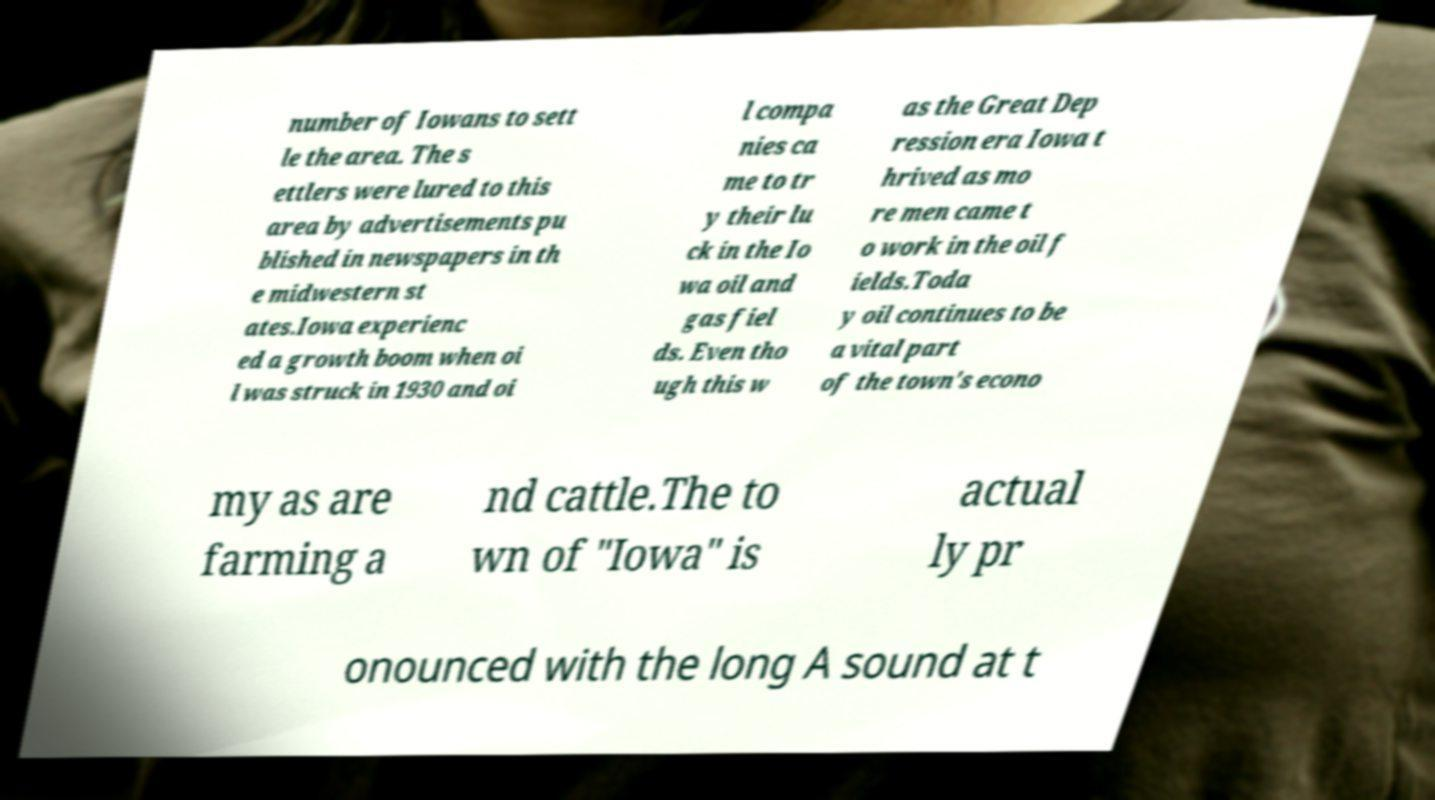What messages or text are displayed in this image? I need them in a readable, typed format. number of Iowans to sett le the area. The s ettlers were lured to this area by advertisements pu blished in newspapers in th e midwestern st ates.Iowa experienc ed a growth boom when oi l was struck in 1930 and oi l compa nies ca me to tr y their lu ck in the Io wa oil and gas fiel ds. Even tho ugh this w as the Great Dep ression era Iowa t hrived as mo re men came t o work in the oil f ields.Toda y oil continues to be a vital part of the town's econo my as are farming a nd cattle.The to wn of "Iowa" is actual ly pr onounced with the long A sound at t 